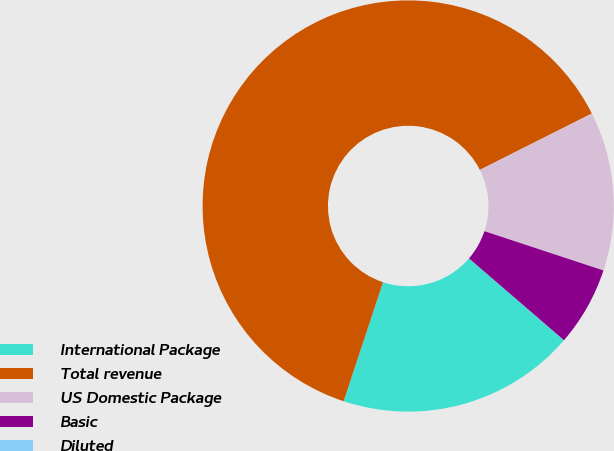Convert chart. <chart><loc_0><loc_0><loc_500><loc_500><pie_chart><fcel>International Package<fcel>Total revenue<fcel>US Domestic Package<fcel>Basic<fcel>Diluted<nl><fcel>18.75%<fcel>62.49%<fcel>12.5%<fcel>6.25%<fcel>0.01%<nl></chart> 